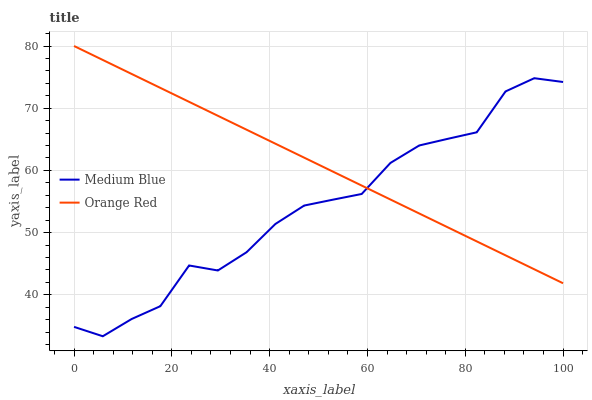Does Medium Blue have the minimum area under the curve?
Answer yes or no. Yes. Does Orange Red have the maximum area under the curve?
Answer yes or no. Yes. Does Orange Red have the minimum area under the curve?
Answer yes or no. No. Is Orange Red the smoothest?
Answer yes or no. Yes. Is Medium Blue the roughest?
Answer yes or no. Yes. Is Orange Red the roughest?
Answer yes or no. No. Does Medium Blue have the lowest value?
Answer yes or no. Yes. Does Orange Red have the lowest value?
Answer yes or no. No. Does Orange Red have the highest value?
Answer yes or no. Yes. Does Orange Red intersect Medium Blue?
Answer yes or no. Yes. Is Orange Red less than Medium Blue?
Answer yes or no. No. Is Orange Red greater than Medium Blue?
Answer yes or no. No. 